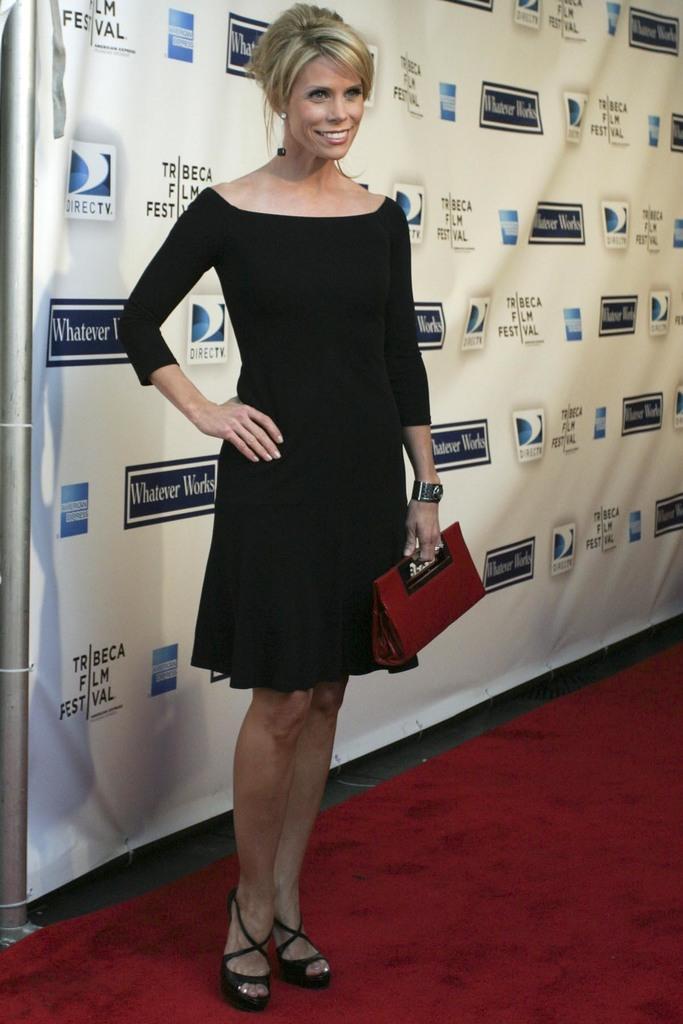How would you summarize this image in a sentence or two? In this image in front there is a person standing on the red carpet and she is wearing a smile on her face. In the background of the image there is a banner. 